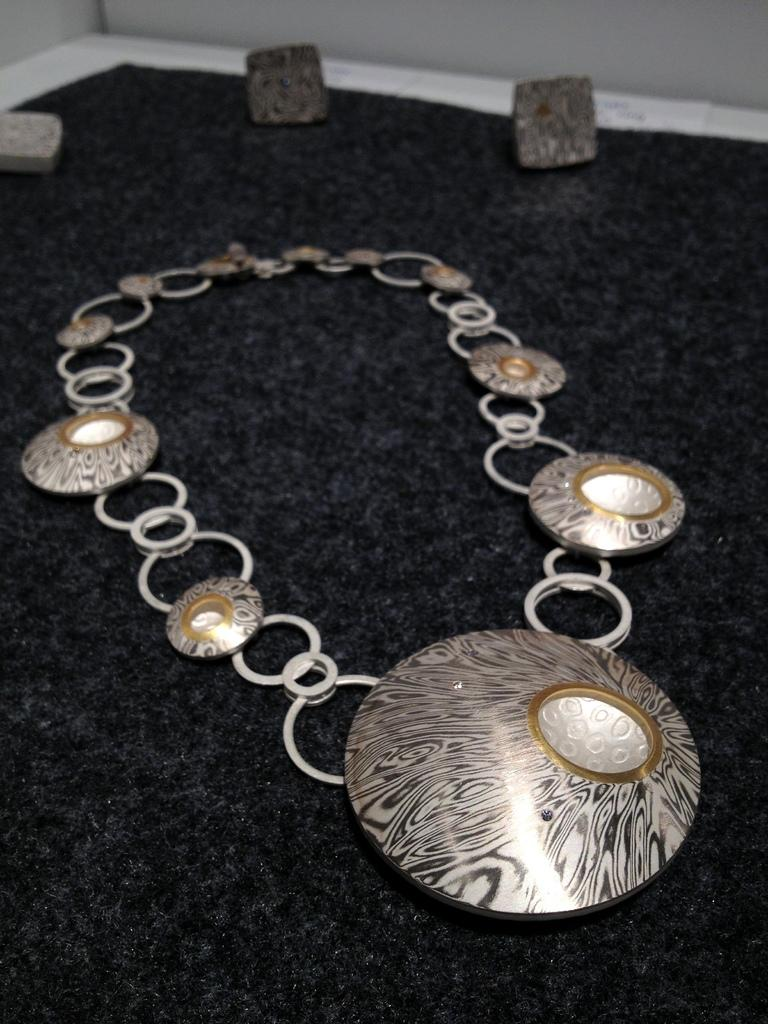What type of jewelry is present in the image? There is a necklace in the image. What other objects are present on the table? There are stones in the image. Where are the necklace and stones located? The necklace and stones are placed on a table. What type of vegetable is being used to hold the stones in the image? There is no vegetable present in the image, and the stones are not being held by any vegetable. 